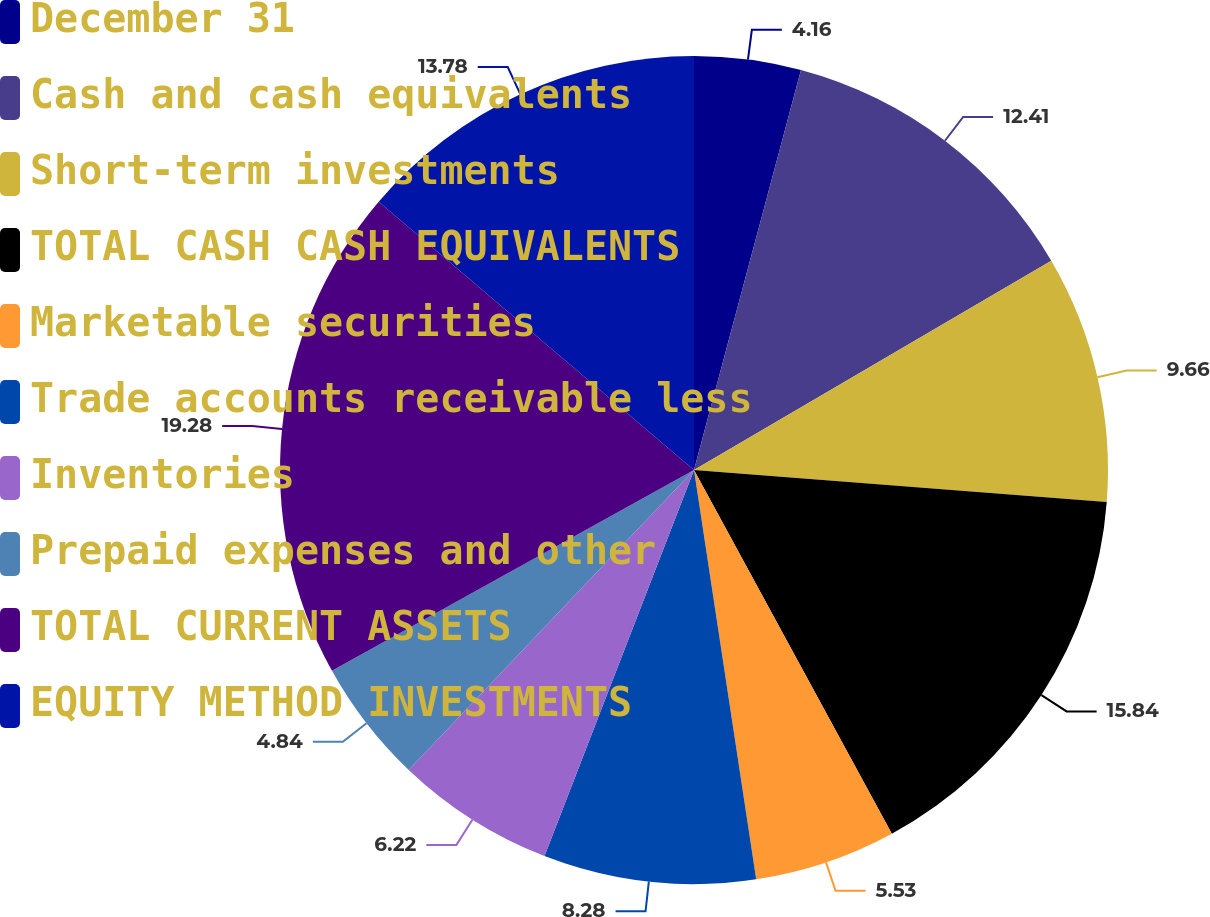Convert chart. <chart><loc_0><loc_0><loc_500><loc_500><pie_chart><fcel>December 31<fcel>Cash and cash equivalents<fcel>Short-term investments<fcel>TOTAL CASH CASH EQUIVALENTS<fcel>Marketable securities<fcel>Trade accounts receivable less<fcel>Inventories<fcel>Prepaid expenses and other<fcel>TOTAL CURRENT ASSETS<fcel>EQUITY METHOD INVESTMENTS<nl><fcel>4.16%<fcel>12.41%<fcel>9.66%<fcel>15.84%<fcel>5.53%<fcel>8.28%<fcel>6.22%<fcel>4.84%<fcel>19.28%<fcel>13.78%<nl></chart> 